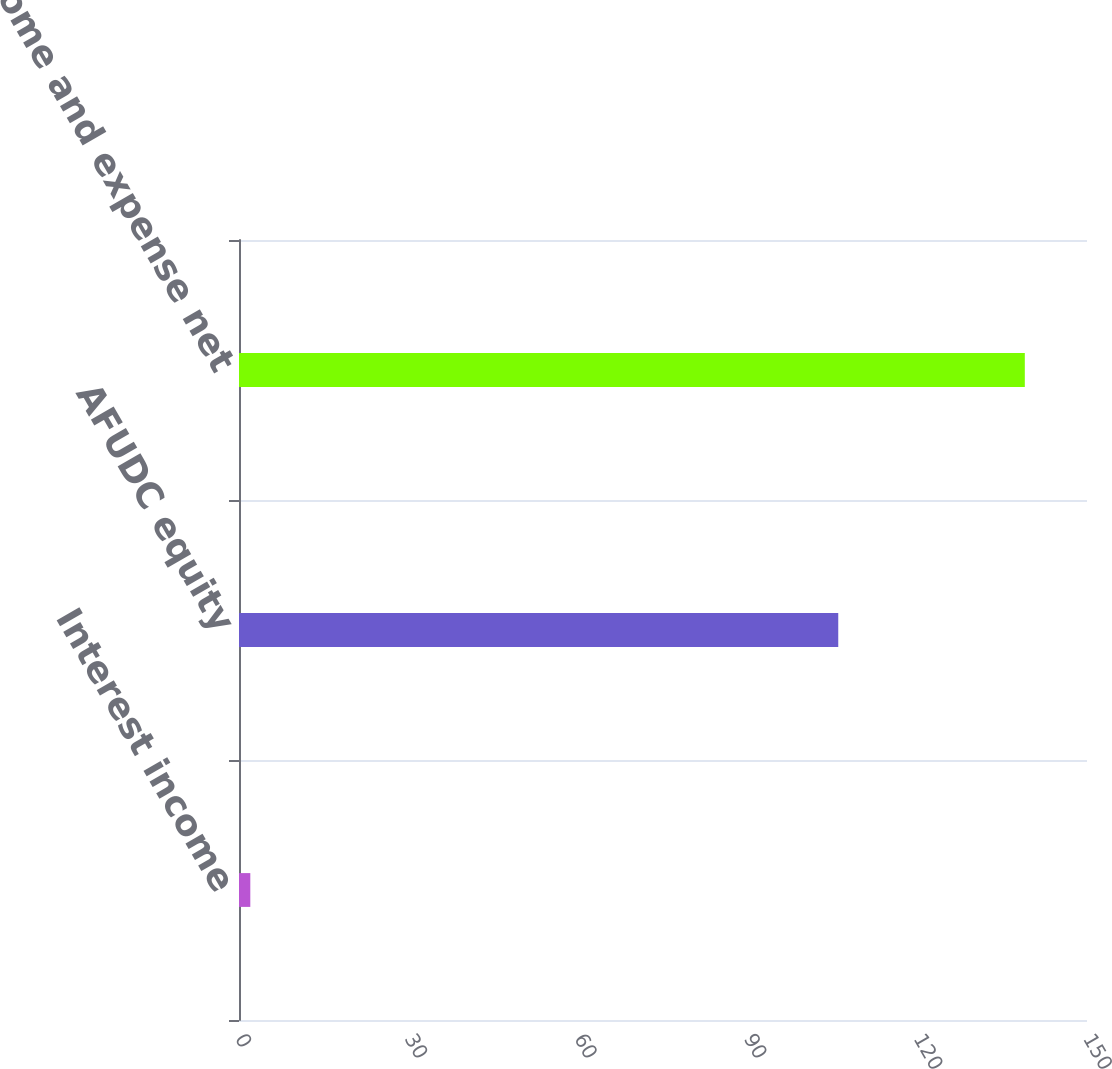<chart> <loc_0><loc_0><loc_500><loc_500><bar_chart><fcel>Interest income<fcel>AFUDC equity<fcel>Other income and expense net<nl><fcel>2<fcel>106<fcel>139<nl></chart> 